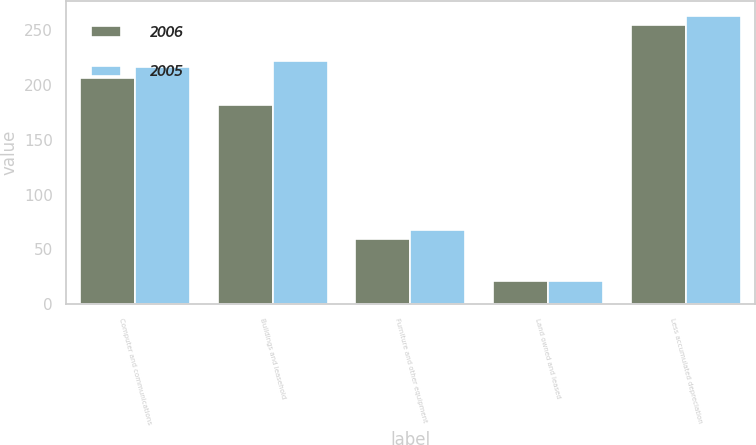Convert chart. <chart><loc_0><loc_0><loc_500><loc_500><stacked_bar_chart><ecel><fcel>Computer and communications<fcel>Buildings and leasehold<fcel>Furniture and other equipment<fcel>Land owned and leased<fcel>Less accumulated depreciation<nl><fcel>2006<fcel>206.3<fcel>181.5<fcel>59.8<fcel>21.5<fcel>254.3<nl><fcel>2005<fcel>216.6<fcel>222.3<fcel>67.7<fcel>21.5<fcel>263.2<nl></chart> 